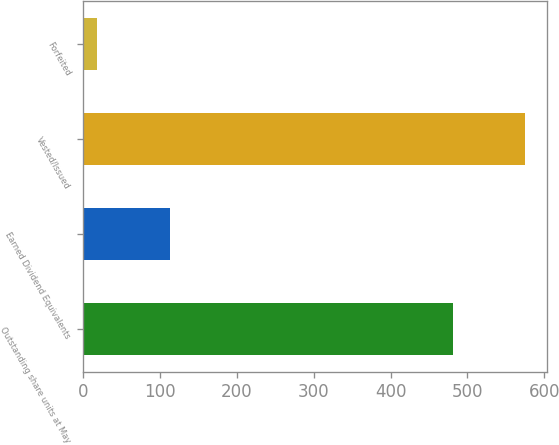Convert chart. <chart><loc_0><loc_0><loc_500><loc_500><bar_chart><fcel>Outstanding share units at May<fcel>Earned Dividend Equivalents<fcel>Vested/Issued<fcel>Forfeited<nl><fcel>481<fcel>112.5<fcel>575.5<fcel>18<nl></chart> 